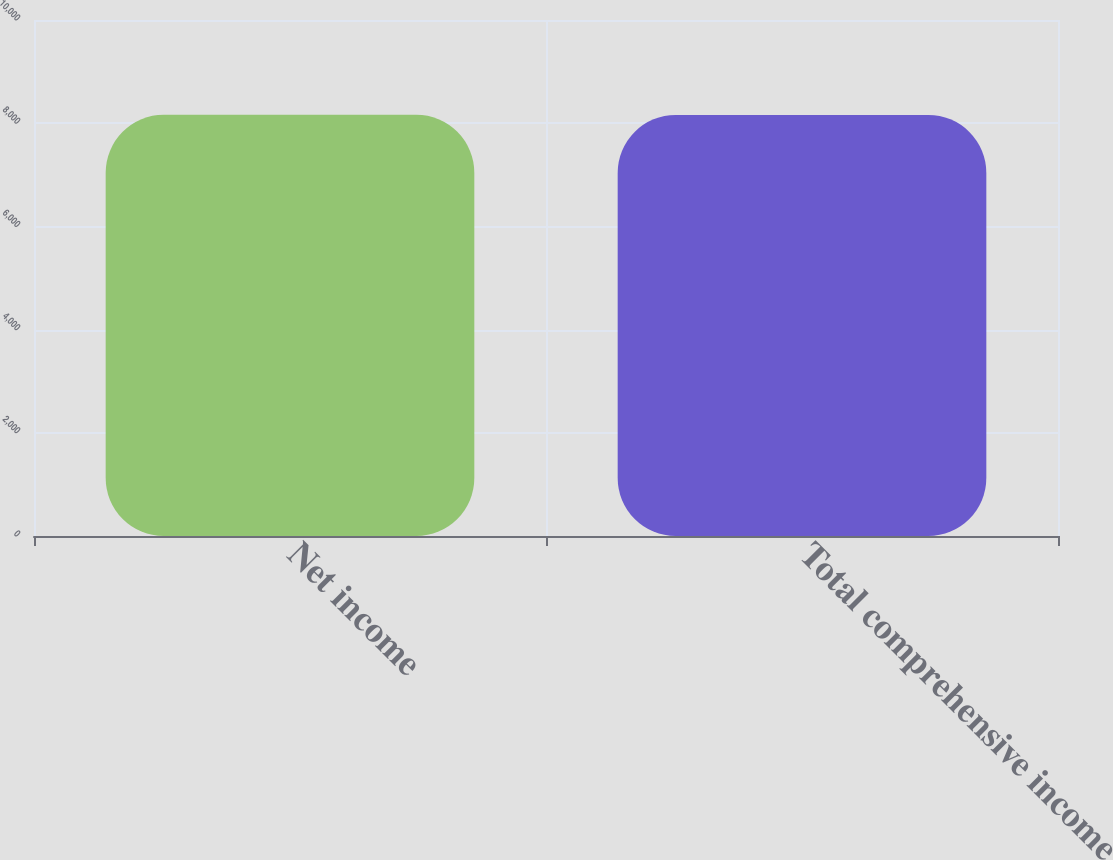Convert chart. <chart><loc_0><loc_0><loc_500><loc_500><bar_chart><fcel>Net income<fcel>Total comprehensive income<nl><fcel>8162<fcel>8161<nl></chart> 